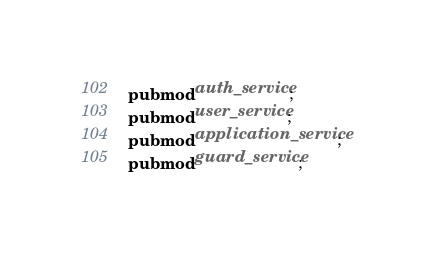<code> <loc_0><loc_0><loc_500><loc_500><_Rust_>pub mod auth_service;
pub mod user_service;
pub mod application_service;
pub mod guard_service;
</code> 